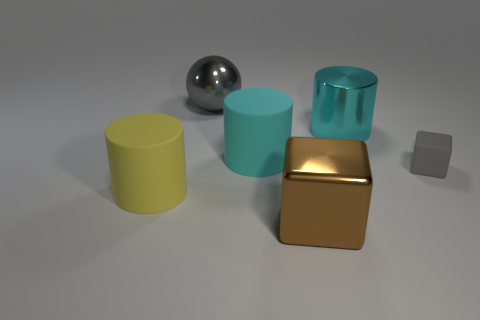What is the lighting like in this scene? The scene is softly lit with diffused lighting, which creates gentle shadows and subtle highlights on the objects. 